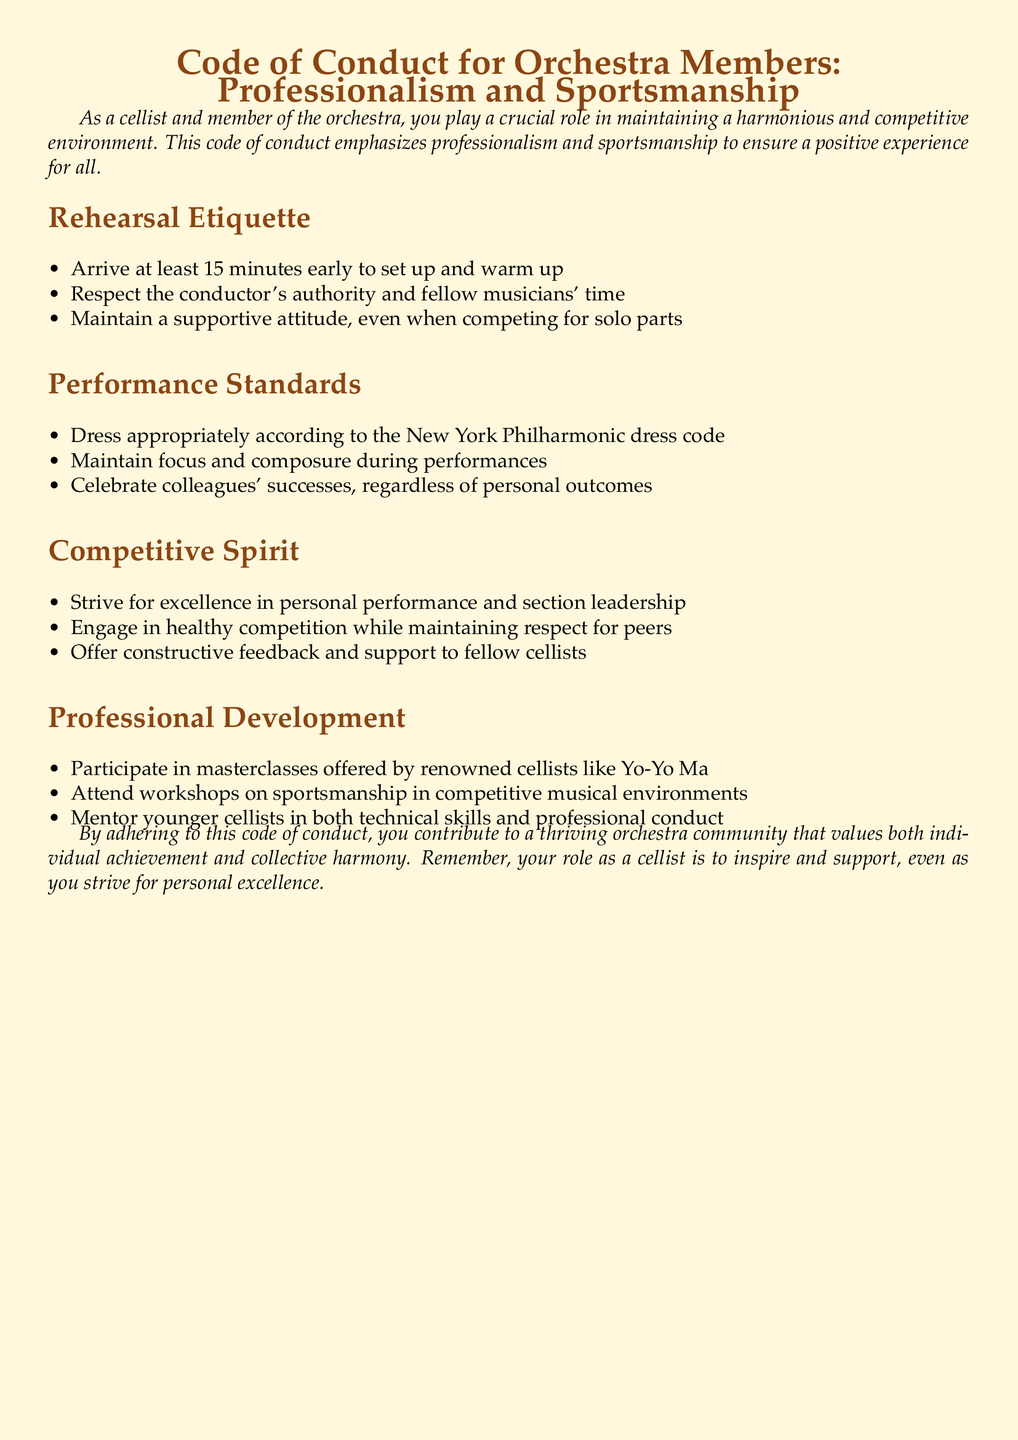What is the title of the document? The title is stated at the beginning of the document and introduces the key topics.
Answer: Code of Conduct for Orchestra Members: Professionalism and Sportsmanship How early should orchestra members arrive at rehearsal? The document specifies a time frame for arrival to ensure proper setup and warm-up.
Answer: 15 minutes Who is a renowned cellist mentioned for masterclasses? The document highlights a notable individual recognized in the music industry for teaching.
Answer: Yo-Yo Ma What should orchestra members maintain during performances? The document outlines a specific behavior that members should exhibit during public performances.
Answer: Focus and composure What is encouraged among colleagues in the "Performance Standards" section? The document emphasizes a particular sentiment towards colleagues' achievements, regardless of personal competition.
Answer: Celebrate colleagues' successes What type of feedback should be offered to fellow cellists? The document describes the nature of the interaction and support expected between members.
Answer: Constructive feedback What is one way to engage in professional development as outlined in the document? The document lists specific activities members can partake in for personal and professional growth.
Answer: Attend workshops What should be respected alongside the conductor's authority? The document indicates other important elements that need respect during rehearsals, ensuring a collective spirit.
Answer: Fellow musicians' time 